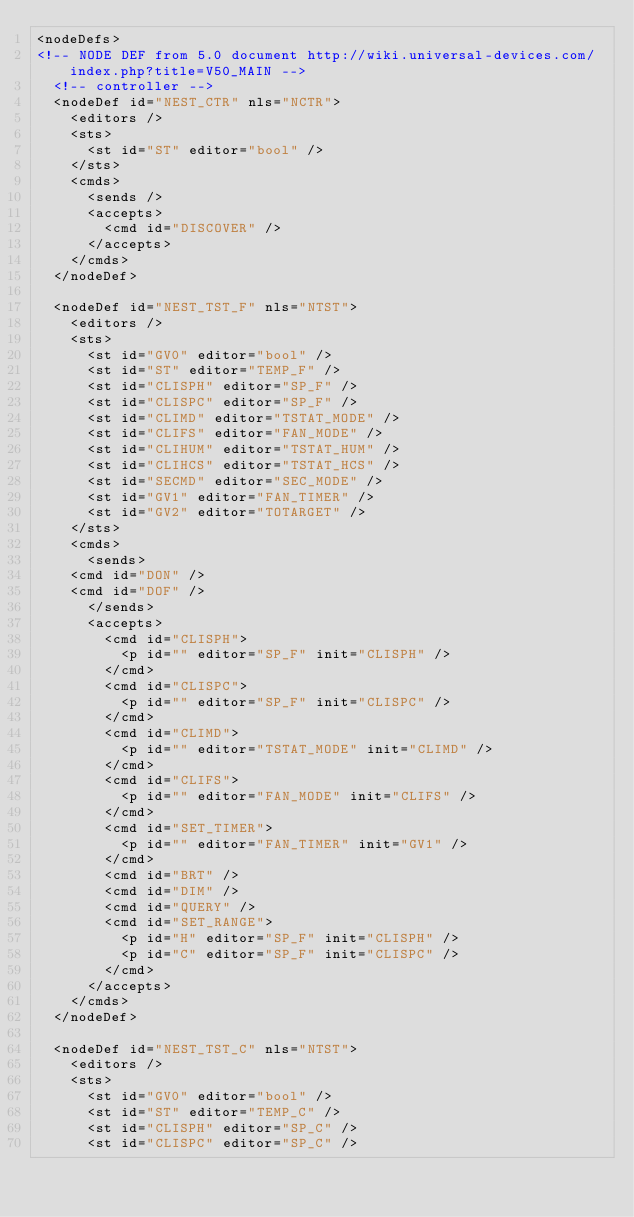Convert code to text. <code><loc_0><loc_0><loc_500><loc_500><_XML_><nodeDefs>
<!-- NODE DEF from 5.0 document http://wiki.universal-devices.com/index.php?title=V50_MAIN -->
  <!-- controller -->
  <nodeDef id="NEST_CTR" nls="NCTR">
    <editors />
    <sts>
      <st id="ST" editor="bool" />
    </sts>
    <cmds>
      <sends />
      <accepts>
        <cmd id="DISCOVER" />
      </accepts>
    </cmds>
  </nodeDef>

  <nodeDef id="NEST_TST_F" nls="NTST">
    <editors />
    <sts>
      <st id="GV0" editor="bool" />
      <st id="ST" editor="TEMP_F" />
      <st id="CLISPH" editor="SP_F" />
      <st id="CLISPC" editor="SP_F" />
      <st id="CLIMD" editor="TSTAT_MODE" />
      <st id="CLIFS" editor="FAN_MODE" />
      <st id="CLIHUM" editor="TSTAT_HUM" />
      <st id="CLIHCS" editor="TSTAT_HCS" />
      <st id="SECMD" editor="SEC_MODE" />
      <st id="GV1" editor="FAN_TIMER" />
      <st id="GV2" editor="TOTARGET" />
    </sts>
    <cmds>
      <sends>
	<cmd id="DON" />
	<cmd id="DOF" />
      </sends>
      <accepts>
        <cmd id="CLISPH">
          <p id="" editor="SP_F" init="CLISPH" />
        </cmd>
        <cmd id="CLISPC">
          <p id="" editor="SP_F" init="CLISPC" />
        </cmd>
        <cmd id="CLIMD">
          <p id="" editor="TSTAT_MODE" init="CLIMD" />
        </cmd>
        <cmd id="CLIFS">
          <p id="" editor="FAN_MODE" init="CLIFS" />
        </cmd>
        <cmd id="SET_TIMER">
          <p id="" editor="FAN_TIMER" init="GV1" />
        </cmd>
        <cmd id="BRT" />
        <cmd id="DIM" />
        <cmd id="QUERY" />
        <cmd id="SET_RANGE">
          <p id="H" editor="SP_F" init="CLISPH" />
          <p id="C" editor="SP_F" init="CLISPC" />
        </cmd>
      </accepts>
    </cmds>
  </nodeDef>

  <nodeDef id="NEST_TST_C" nls="NTST">
    <editors />
    <sts>
      <st id="GV0" editor="bool" />
      <st id="ST" editor="TEMP_C" />
      <st id="CLISPH" editor="SP_C" />
      <st id="CLISPC" editor="SP_C" /></code> 